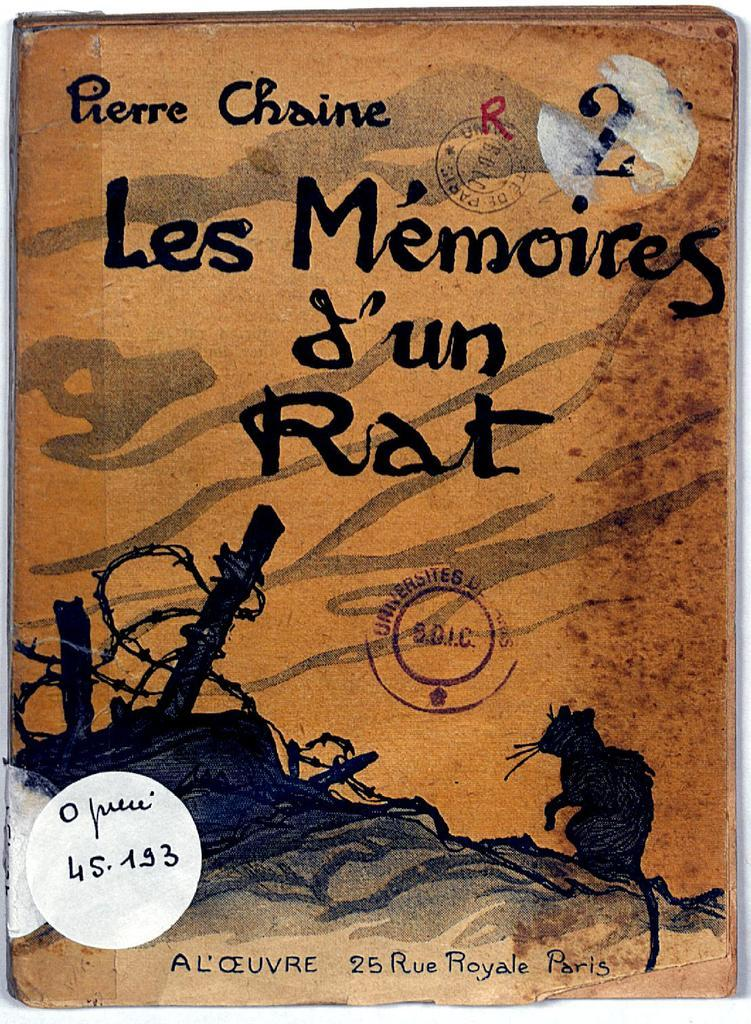<image>
Render a clear and concise summary of the photo. orange and black book, les m'emories j'un rat by pierre chaine 